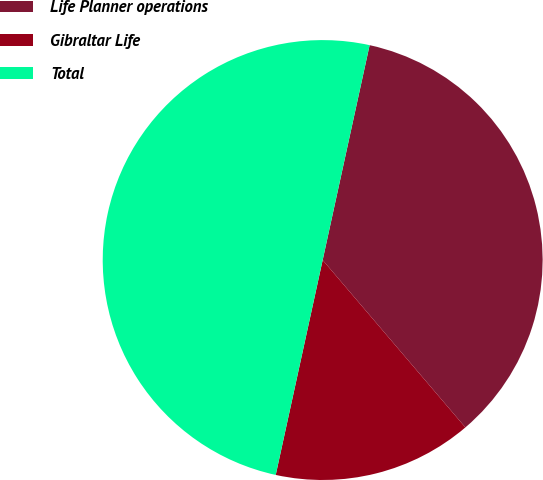Convert chart. <chart><loc_0><loc_0><loc_500><loc_500><pie_chart><fcel>Life Planner operations<fcel>Gibraltar Life<fcel>Total<nl><fcel>35.34%<fcel>14.66%<fcel>50.0%<nl></chart> 